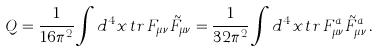<formula> <loc_0><loc_0><loc_500><loc_500>Q = \frac { 1 } { 1 6 \pi ^ { 2 } } \int d ^ { 4 } x \, t r \, F _ { \mu \nu } \tilde { F } _ { \mu \nu } = \frac { 1 } { 3 2 \pi ^ { 2 } } \int d ^ { 4 } x \, t r \, F _ { \mu \nu } ^ { a } \tilde { F } _ { \mu \nu } ^ { a } \, .</formula> 